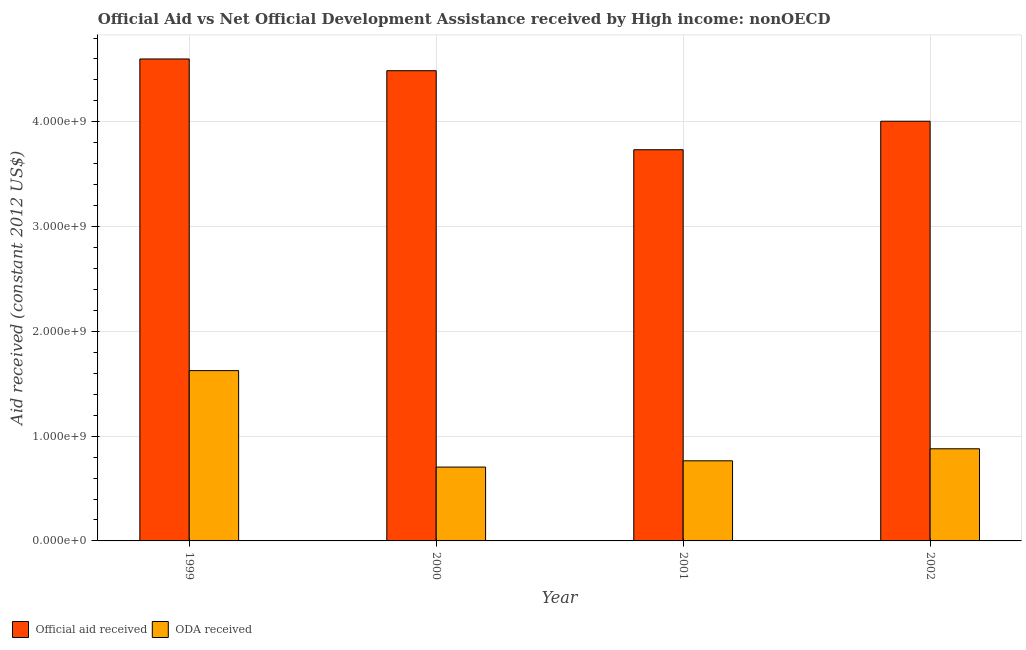How many different coloured bars are there?
Provide a short and direct response. 2. How many groups of bars are there?
Give a very brief answer. 4. How many bars are there on the 4th tick from the left?
Offer a terse response. 2. What is the label of the 3rd group of bars from the left?
Your answer should be very brief. 2001. In how many cases, is the number of bars for a given year not equal to the number of legend labels?
Offer a very short reply. 0. What is the oda received in 2001?
Give a very brief answer. 7.65e+08. Across all years, what is the maximum oda received?
Your response must be concise. 1.63e+09. Across all years, what is the minimum oda received?
Make the answer very short. 7.05e+08. In which year was the official aid received minimum?
Give a very brief answer. 2001. What is the total oda received in the graph?
Your answer should be compact. 3.97e+09. What is the difference between the oda received in 2000 and that in 2002?
Your answer should be very brief. -1.75e+08. What is the difference between the official aid received in 2000 and the oda received in 2002?
Offer a very short reply. 4.82e+08. What is the average oda received per year?
Make the answer very short. 9.94e+08. In the year 1999, what is the difference between the oda received and official aid received?
Provide a succinct answer. 0. What is the ratio of the oda received in 2001 to that in 2002?
Give a very brief answer. 0.87. What is the difference between the highest and the second highest official aid received?
Ensure brevity in your answer.  1.12e+08. What is the difference between the highest and the lowest official aid received?
Your response must be concise. 8.66e+08. In how many years, is the official aid received greater than the average official aid received taken over all years?
Your response must be concise. 2. What does the 1st bar from the left in 2002 represents?
Your answer should be very brief. Official aid received. What does the 1st bar from the right in 2000 represents?
Your answer should be compact. ODA received. Are all the bars in the graph horizontal?
Your answer should be very brief. No. Does the graph contain grids?
Offer a terse response. Yes. Where does the legend appear in the graph?
Give a very brief answer. Bottom left. How many legend labels are there?
Ensure brevity in your answer.  2. What is the title of the graph?
Keep it short and to the point. Official Aid vs Net Official Development Assistance received by High income: nonOECD . Does "Exports of goods" appear as one of the legend labels in the graph?
Provide a succinct answer. No. What is the label or title of the Y-axis?
Offer a terse response. Aid received (constant 2012 US$). What is the Aid received (constant 2012 US$) of Official aid received in 1999?
Ensure brevity in your answer.  4.60e+09. What is the Aid received (constant 2012 US$) in ODA received in 1999?
Your answer should be compact. 1.63e+09. What is the Aid received (constant 2012 US$) of Official aid received in 2000?
Your answer should be very brief. 4.49e+09. What is the Aid received (constant 2012 US$) of ODA received in 2000?
Provide a short and direct response. 7.05e+08. What is the Aid received (constant 2012 US$) in Official aid received in 2001?
Provide a succinct answer. 3.73e+09. What is the Aid received (constant 2012 US$) of ODA received in 2001?
Offer a terse response. 7.65e+08. What is the Aid received (constant 2012 US$) of Official aid received in 2002?
Your answer should be compact. 4.01e+09. What is the Aid received (constant 2012 US$) in ODA received in 2002?
Offer a terse response. 8.79e+08. Across all years, what is the maximum Aid received (constant 2012 US$) of Official aid received?
Your answer should be very brief. 4.60e+09. Across all years, what is the maximum Aid received (constant 2012 US$) in ODA received?
Provide a short and direct response. 1.63e+09. Across all years, what is the minimum Aid received (constant 2012 US$) of Official aid received?
Ensure brevity in your answer.  3.73e+09. Across all years, what is the minimum Aid received (constant 2012 US$) of ODA received?
Ensure brevity in your answer.  7.05e+08. What is the total Aid received (constant 2012 US$) in Official aid received in the graph?
Make the answer very short. 1.68e+1. What is the total Aid received (constant 2012 US$) in ODA received in the graph?
Provide a short and direct response. 3.97e+09. What is the difference between the Aid received (constant 2012 US$) in Official aid received in 1999 and that in 2000?
Your answer should be compact. 1.12e+08. What is the difference between the Aid received (constant 2012 US$) in ODA received in 1999 and that in 2000?
Provide a succinct answer. 9.21e+08. What is the difference between the Aid received (constant 2012 US$) of Official aid received in 1999 and that in 2001?
Offer a terse response. 8.66e+08. What is the difference between the Aid received (constant 2012 US$) in ODA received in 1999 and that in 2001?
Provide a short and direct response. 8.61e+08. What is the difference between the Aid received (constant 2012 US$) of Official aid received in 1999 and that in 2002?
Offer a terse response. 5.94e+08. What is the difference between the Aid received (constant 2012 US$) in ODA received in 1999 and that in 2002?
Ensure brevity in your answer.  7.46e+08. What is the difference between the Aid received (constant 2012 US$) of Official aid received in 2000 and that in 2001?
Your answer should be very brief. 7.54e+08. What is the difference between the Aid received (constant 2012 US$) of ODA received in 2000 and that in 2001?
Make the answer very short. -5.99e+07. What is the difference between the Aid received (constant 2012 US$) of Official aid received in 2000 and that in 2002?
Offer a very short reply. 4.82e+08. What is the difference between the Aid received (constant 2012 US$) in ODA received in 2000 and that in 2002?
Offer a terse response. -1.75e+08. What is the difference between the Aid received (constant 2012 US$) of Official aid received in 2001 and that in 2002?
Provide a short and direct response. -2.72e+08. What is the difference between the Aid received (constant 2012 US$) in ODA received in 2001 and that in 2002?
Your answer should be very brief. -1.15e+08. What is the difference between the Aid received (constant 2012 US$) of Official aid received in 1999 and the Aid received (constant 2012 US$) of ODA received in 2000?
Your answer should be compact. 3.90e+09. What is the difference between the Aid received (constant 2012 US$) in Official aid received in 1999 and the Aid received (constant 2012 US$) in ODA received in 2001?
Your answer should be compact. 3.84e+09. What is the difference between the Aid received (constant 2012 US$) in Official aid received in 1999 and the Aid received (constant 2012 US$) in ODA received in 2002?
Make the answer very short. 3.72e+09. What is the difference between the Aid received (constant 2012 US$) of Official aid received in 2000 and the Aid received (constant 2012 US$) of ODA received in 2001?
Provide a succinct answer. 3.72e+09. What is the difference between the Aid received (constant 2012 US$) of Official aid received in 2000 and the Aid received (constant 2012 US$) of ODA received in 2002?
Offer a very short reply. 3.61e+09. What is the difference between the Aid received (constant 2012 US$) of Official aid received in 2001 and the Aid received (constant 2012 US$) of ODA received in 2002?
Provide a short and direct response. 2.85e+09. What is the average Aid received (constant 2012 US$) in Official aid received per year?
Your answer should be compact. 4.21e+09. What is the average Aid received (constant 2012 US$) in ODA received per year?
Provide a succinct answer. 9.94e+08. In the year 1999, what is the difference between the Aid received (constant 2012 US$) in Official aid received and Aid received (constant 2012 US$) in ODA received?
Offer a very short reply. 2.97e+09. In the year 2000, what is the difference between the Aid received (constant 2012 US$) in Official aid received and Aid received (constant 2012 US$) in ODA received?
Your answer should be very brief. 3.78e+09. In the year 2001, what is the difference between the Aid received (constant 2012 US$) of Official aid received and Aid received (constant 2012 US$) of ODA received?
Your response must be concise. 2.97e+09. In the year 2002, what is the difference between the Aid received (constant 2012 US$) in Official aid received and Aid received (constant 2012 US$) in ODA received?
Keep it short and to the point. 3.13e+09. What is the ratio of the Aid received (constant 2012 US$) of Official aid received in 1999 to that in 2000?
Give a very brief answer. 1.02. What is the ratio of the Aid received (constant 2012 US$) of ODA received in 1999 to that in 2000?
Ensure brevity in your answer.  2.31. What is the ratio of the Aid received (constant 2012 US$) in Official aid received in 1999 to that in 2001?
Your answer should be compact. 1.23. What is the ratio of the Aid received (constant 2012 US$) in ODA received in 1999 to that in 2001?
Offer a terse response. 2.13. What is the ratio of the Aid received (constant 2012 US$) in Official aid received in 1999 to that in 2002?
Your response must be concise. 1.15. What is the ratio of the Aid received (constant 2012 US$) in ODA received in 1999 to that in 2002?
Your response must be concise. 1.85. What is the ratio of the Aid received (constant 2012 US$) in Official aid received in 2000 to that in 2001?
Ensure brevity in your answer.  1.2. What is the ratio of the Aid received (constant 2012 US$) of ODA received in 2000 to that in 2001?
Your answer should be compact. 0.92. What is the ratio of the Aid received (constant 2012 US$) of Official aid received in 2000 to that in 2002?
Ensure brevity in your answer.  1.12. What is the ratio of the Aid received (constant 2012 US$) of ODA received in 2000 to that in 2002?
Keep it short and to the point. 0.8. What is the ratio of the Aid received (constant 2012 US$) in Official aid received in 2001 to that in 2002?
Provide a succinct answer. 0.93. What is the ratio of the Aid received (constant 2012 US$) of ODA received in 2001 to that in 2002?
Provide a succinct answer. 0.87. What is the difference between the highest and the second highest Aid received (constant 2012 US$) in Official aid received?
Your answer should be compact. 1.12e+08. What is the difference between the highest and the second highest Aid received (constant 2012 US$) of ODA received?
Provide a succinct answer. 7.46e+08. What is the difference between the highest and the lowest Aid received (constant 2012 US$) in Official aid received?
Keep it short and to the point. 8.66e+08. What is the difference between the highest and the lowest Aid received (constant 2012 US$) of ODA received?
Your answer should be very brief. 9.21e+08. 